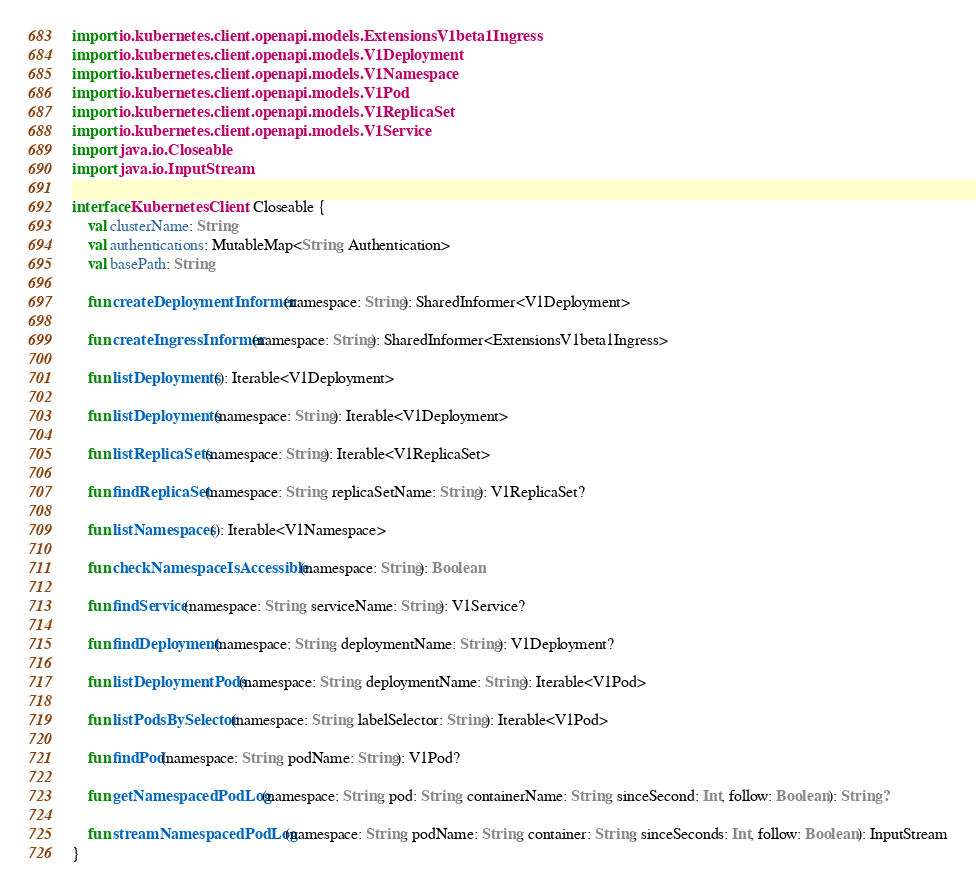<code> <loc_0><loc_0><loc_500><loc_500><_Kotlin_>import io.kubernetes.client.openapi.models.ExtensionsV1beta1Ingress
import io.kubernetes.client.openapi.models.V1Deployment
import io.kubernetes.client.openapi.models.V1Namespace
import io.kubernetes.client.openapi.models.V1Pod
import io.kubernetes.client.openapi.models.V1ReplicaSet
import io.kubernetes.client.openapi.models.V1Service
import java.io.Closeable
import java.io.InputStream

interface KubernetesClient : Closeable {
    val clusterName: String
    val authentications: MutableMap<String, Authentication>
    val basePath: String

    fun createDeploymentInformer(namespace: String): SharedInformer<V1Deployment>

    fun createIngressInformer(namespace: String): SharedInformer<ExtensionsV1beta1Ingress>

    fun listDeployments(): Iterable<V1Deployment>

    fun listDeployments(namespace: String): Iterable<V1Deployment>

    fun listReplicaSets(namespace: String): Iterable<V1ReplicaSet>

    fun findReplicaSet(namespace: String, replicaSetName: String): V1ReplicaSet?

    fun listNamespaces(): Iterable<V1Namespace>

    fun checkNamespaceIsAccessible(namespace: String): Boolean

    fun findService(namespace: String, serviceName: String): V1Service?

    fun findDeployment(namespace: String, deploymentName: String): V1Deployment?

    fun listDeploymentPods(namespace: String, deploymentName: String): Iterable<V1Pod>

    fun listPodsBySelector(namespace: String, labelSelector: String): Iterable<V1Pod>

    fun findPod(namespace: String, podName: String): V1Pod?

    fun getNamespacedPodLog(namespace: String, pod: String, containerName: String, sinceSecond: Int, follow: Boolean): String?

    fun streamNamespacedPodLog(namespace: String, podName: String, container: String, sinceSeconds: Int, follow: Boolean): InputStream
}</code> 